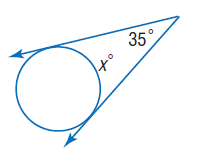Answer the mathemtical geometry problem and directly provide the correct option letter.
Question: Find x. Assume that segments that appear to be tangent are tangent.
Choices: A: 35 B: 70 C: 145 D: 155 C 